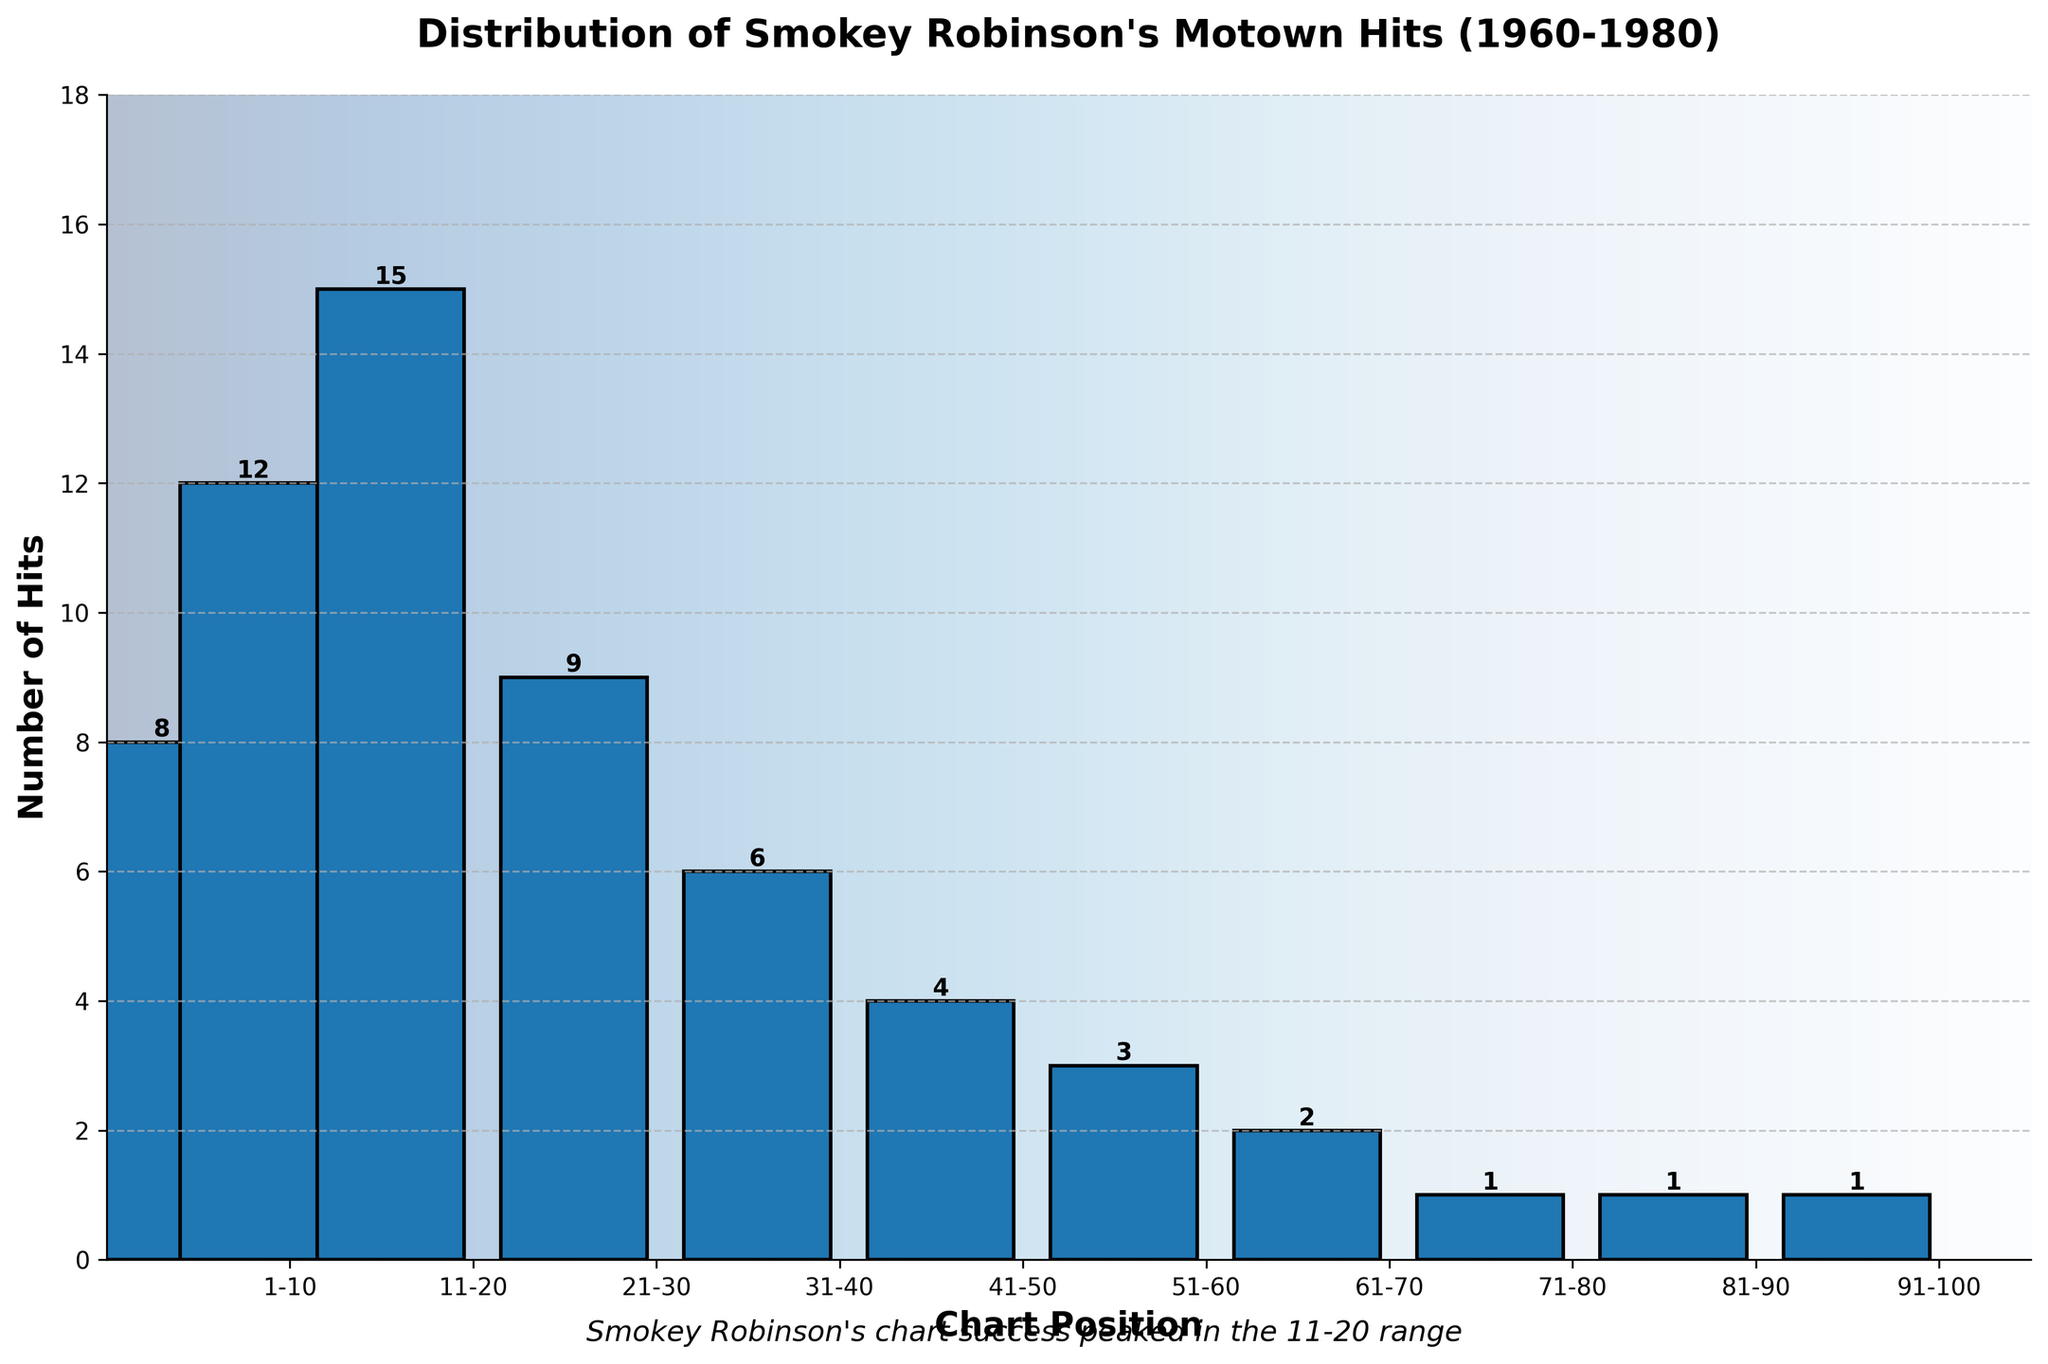How many hits were in the 31-40 chart position range? In the histogram, look for the bar corresponding to the 31-40 chart position range and read the height of the bar, which represents the number of hits.
Answer: 6 Which chart position range had the most hits? Identify the tallest bar in the histogram. The x-axis label of this bar will indicate the chart position range with the most hits.
Answer: 11-20 What is the total number of hits across all chart position ranges? Add up all the numbers from the y-axis values of each bar in the histogram: 8 + 12 + 15 + 9 + 6 + 4 + 3 + 2 + 1 + 1 + 1.
Answer: 62 How many more hits did the 1-5 chart position range have compared to the 41-50 chart position range? Subtract the number of hits in the 41-50 chart position range from the 1-5 chart position range: 8 - 4.
Answer: 4 Between the 21-30 and 31-40 chart position ranges, which had fewer hits and by how many? Compare the heights of the bars for the 21-30 and 31-40 chart position ranges. The 31-40 chart position range (6 hits) had fewer hits than the 21-30 range (9 hits). Subtract: 9 - 6.
Answer: 31-40 by 3 Does the number of hits consistently decrease as the chart position range increases? Visually inspect the histogram to see if the bar heights decrease consistently from left to right. Note any exceptions where a bar is taller than the previous one.
Answer: No What is the combined number of hits for the top three chart position ranges? Add together the number of hits from the three chart position ranges with the most hits: 11-20 (15), 6-10 (12), 1-5 (8).
Answer: 35 Which chart position ranges have fewer than 5 hits, and how many such ranges are there? Count the number of bars in the histogram that have a height less than 5. The chart position ranges are 51-60 (3), 61-70 (2), 71-80 (1), 81-90 (1), and 91-100 (1).
Answer: 5 ranges What is the average number of hits for the chart position ranges 1-10? Calculate the average of the hits in the 1-5 and 6-10 chart position ranges: (8 + 12) / 2.
Answer: 10 What's the difference between the highest and lowest number of hits in any chart position range? Identify the chart position range with the highest number of hits (11-20, 15 hits) and the lowest number of hits (71-80, 81-90, 91-100, each with 1 hit). Subtract: 15 - 1.
Answer: 14 